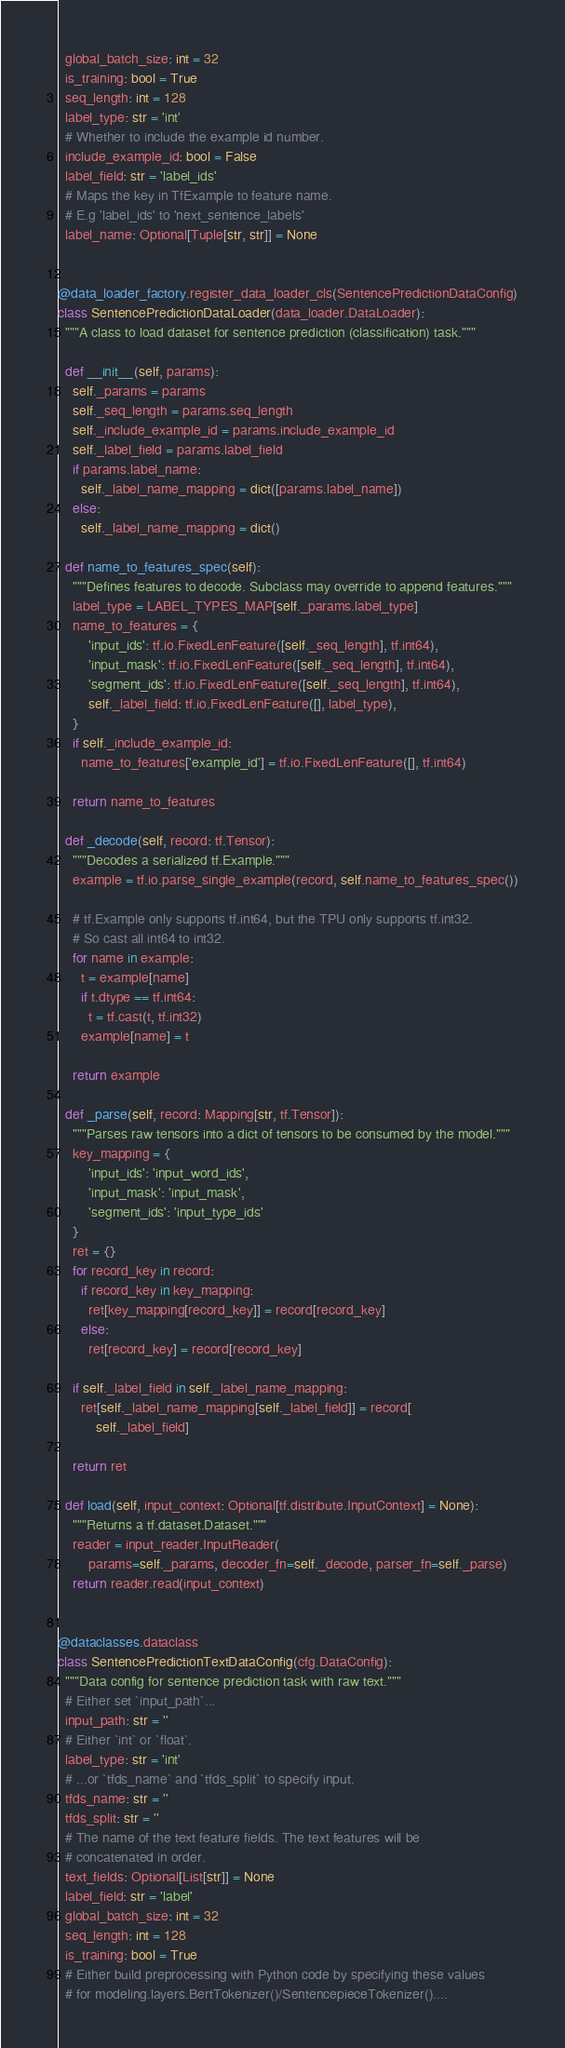<code> <loc_0><loc_0><loc_500><loc_500><_Python_>  global_batch_size: int = 32
  is_training: bool = True
  seq_length: int = 128
  label_type: str = 'int'
  # Whether to include the example id number.
  include_example_id: bool = False
  label_field: str = 'label_ids'
  # Maps the key in TfExample to feature name.
  # E.g 'label_ids' to 'next_sentence_labels'
  label_name: Optional[Tuple[str, str]] = None


@data_loader_factory.register_data_loader_cls(SentencePredictionDataConfig)
class SentencePredictionDataLoader(data_loader.DataLoader):
  """A class to load dataset for sentence prediction (classification) task."""

  def __init__(self, params):
    self._params = params
    self._seq_length = params.seq_length
    self._include_example_id = params.include_example_id
    self._label_field = params.label_field
    if params.label_name:
      self._label_name_mapping = dict([params.label_name])
    else:
      self._label_name_mapping = dict()

  def name_to_features_spec(self):
    """Defines features to decode. Subclass may override to append features."""
    label_type = LABEL_TYPES_MAP[self._params.label_type]
    name_to_features = {
        'input_ids': tf.io.FixedLenFeature([self._seq_length], tf.int64),
        'input_mask': tf.io.FixedLenFeature([self._seq_length], tf.int64),
        'segment_ids': tf.io.FixedLenFeature([self._seq_length], tf.int64),
        self._label_field: tf.io.FixedLenFeature([], label_type),
    }
    if self._include_example_id:
      name_to_features['example_id'] = tf.io.FixedLenFeature([], tf.int64)

    return name_to_features

  def _decode(self, record: tf.Tensor):
    """Decodes a serialized tf.Example."""
    example = tf.io.parse_single_example(record, self.name_to_features_spec())

    # tf.Example only supports tf.int64, but the TPU only supports tf.int32.
    # So cast all int64 to int32.
    for name in example:
      t = example[name]
      if t.dtype == tf.int64:
        t = tf.cast(t, tf.int32)
      example[name] = t

    return example

  def _parse(self, record: Mapping[str, tf.Tensor]):
    """Parses raw tensors into a dict of tensors to be consumed by the model."""
    key_mapping = {
        'input_ids': 'input_word_ids',
        'input_mask': 'input_mask',
        'segment_ids': 'input_type_ids'
    }
    ret = {}
    for record_key in record:
      if record_key in key_mapping:
        ret[key_mapping[record_key]] = record[record_key]
      else:
        ret[record_key] = record[record_key]

    if self._label_field in self._label_name_mapping:
      ret[self._label_name_mapping[self._label_field]] = record[
          self._label_field]

    return ret

  def load(self, input_context: Optional[tf.distribute.InputContext] = None):
    """Returns a tf.dataset.Dataset."""
    reader = input_reader.InputReader(
        params=self._params, decoder_fn=self._decode, parser_fn=self._parse)
    return reader.read(input_context)


@dataclasses.dataclass
class SentencePredictionTextDataConfig(cfg.DataConfig):
  """Data config for sentence prediction task with raw text."""
  # Either set `input_path`...
  input_path: str = ''
  # Either `int` or `float`.
  label_type: str = 'int'
  # ...or `tfds_name` and `tfds_split` to specify input.
  tfds_name: str = ''
  tfds_split: str = ''
  # The name of the text feature fields. The text features will be
  # concatenated in order.
  text_fields: Optional[List[str]] = None
  label_field: str = 'label'
  global_batch_size: int = 32
  seq_length: int = 128
  is_training: bool = True
  # Either build preprocessing with Python code by specifying these values
  # for modeling.layers.BertTokenizer()/SentencepieceTokenizer()....</code> 